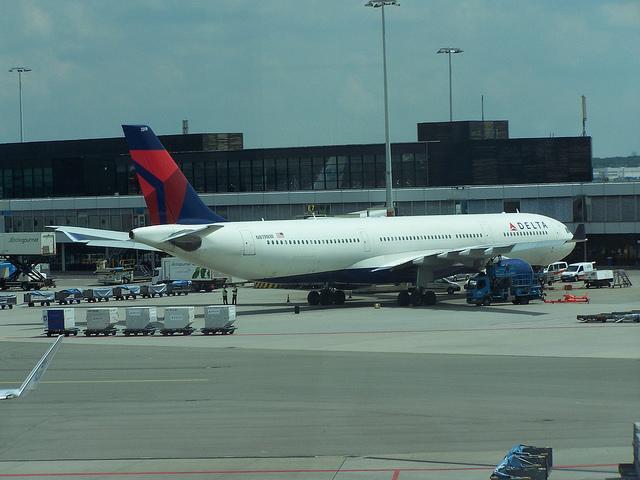Which country does this aircraft brand originate from?
Answer the question by selecting the correct answer among the 4 following choices.
Options: Canada, america, chile, mexico. America. 